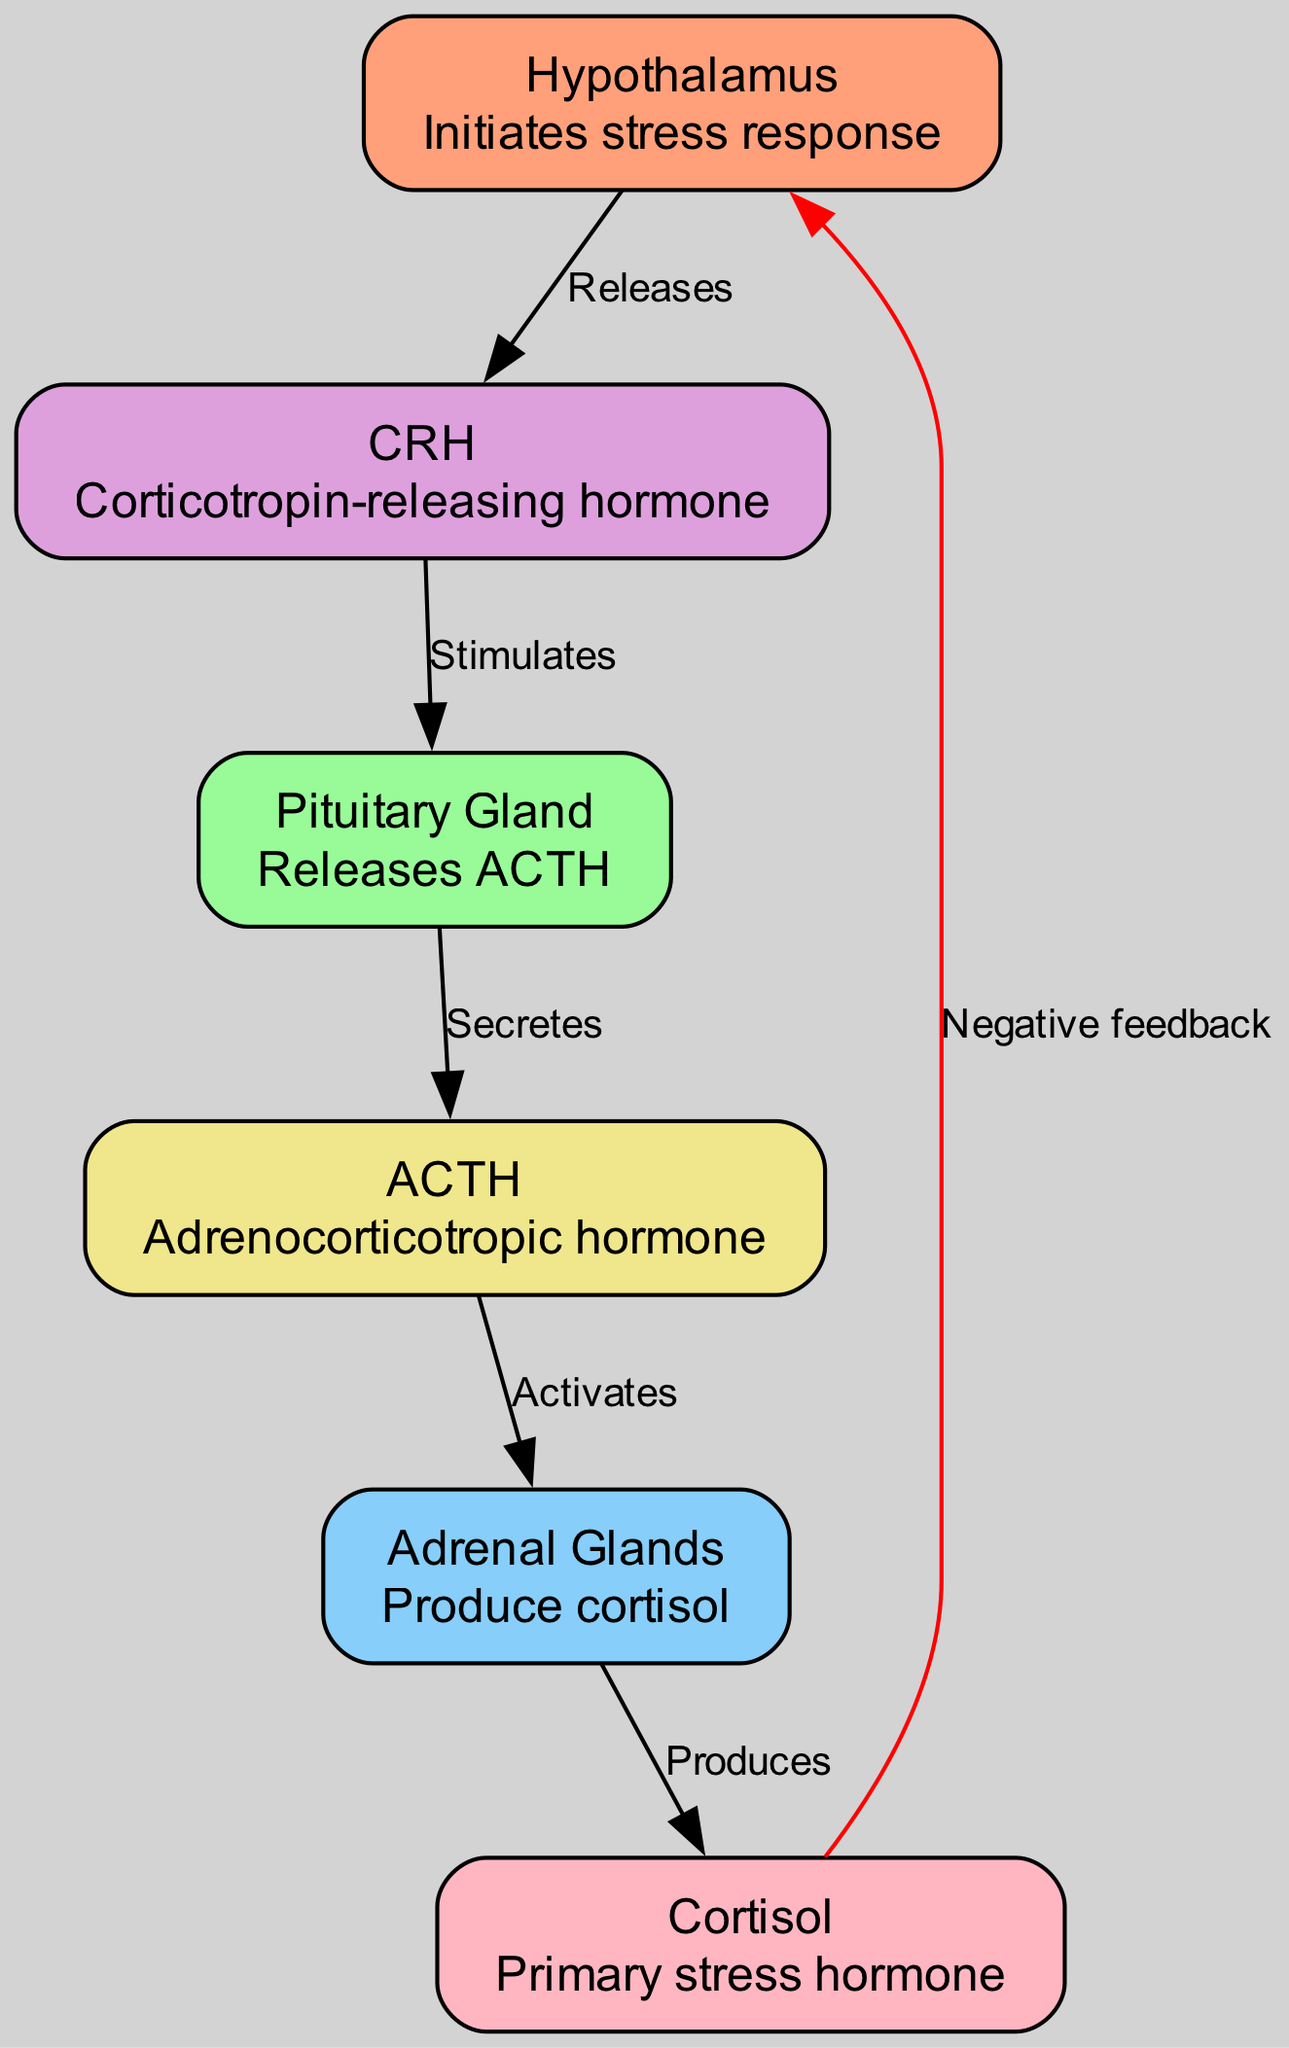What is released by the hypothalamus? The diagram shows that the hypothalamus releases CRH, as indicated by the directed edge labeled "Releases" pointing to the CRH node.
Answer: CRH What does ACTH stimulate? According to the diagram, ACTH stimulates the adrenal glands, which is depicted by the directed edge labeled "Activates" pointing to the adrenal node from the ACTH node.
Answer: Adrenal Glands How many nodes are present in the diagram? By counting the node entries in the provided data, we find there are 6 distinct nodes representing different components of the stress response pathway.
Answer: 6 Which hormone is produced by the adrenal glands? The diagram indicates that the adrenal glands produce cortisol, as shown by the directed edge labeled "Produces" linking the adrenal node to the cortisol node.
Answer: Cortisol What feedback mechanism is indicated in the diagram? The diagram highlights a negative feedback mechanism where cortisol is shown to exert a feedback effect on the hypothalamus, illustrated by the directed edge labeled "Negative feedback" pointing back to the hypothalamus.
Answer: Negative feedback What hormone does the pituitary gland secrete? The diagram states that the pituitary gland secretes ACTH, indicated by the edge labeled "Secretes" linking the pituitary node to the ACTH node.
Answer: ACTH What is the primary role of cortisol in the stress response? Based on the diagram, the primary role of cortisol is to act as the primary stress hormone, encompassing its crucial function in the stress response process.
Answer: Primary stress hormone Which node does CRH stimulate? The diagram explicitly shows that CRH stimulates the pituitary gland, as indicated by the edge labeled "Stimulates" directed towards the pituitary node.
Answer: Pituitary Gland 